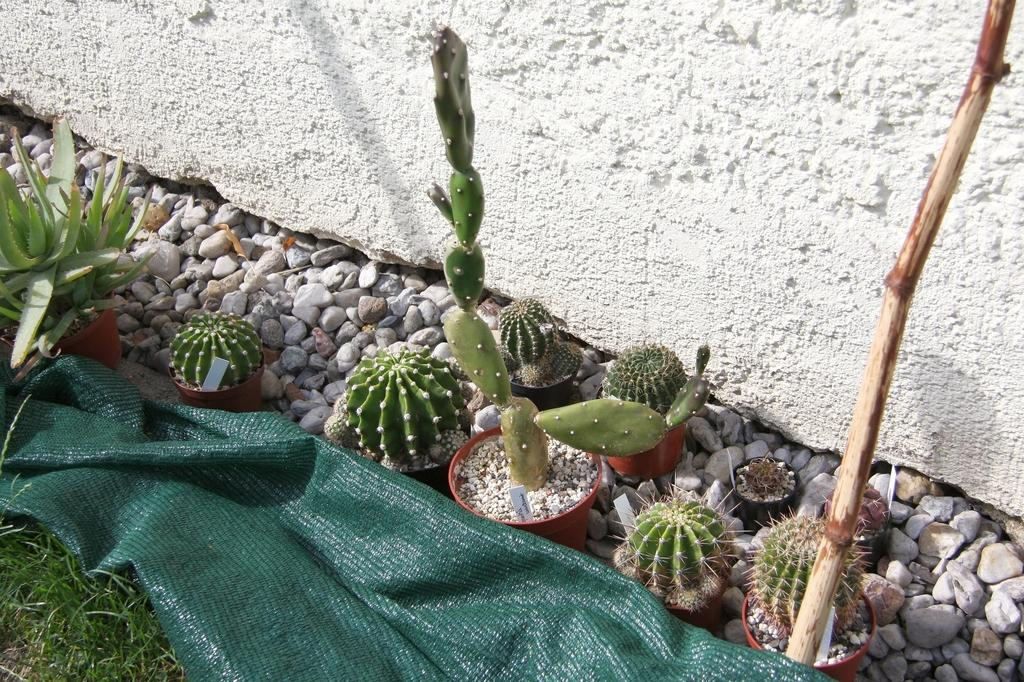What type of plants are on the ground in the image? There are cactus plants on the ground in the image. What is beneath the plants? There are stones below the plants. What is at the bottom of the image? There is a cloth and grass at the bottom of the image. What is visible at the top of the image? There is a wall at the top of the image. How much smoke can be seen coming from the notebook in the image? There is no notebook or smoke present in the image. 